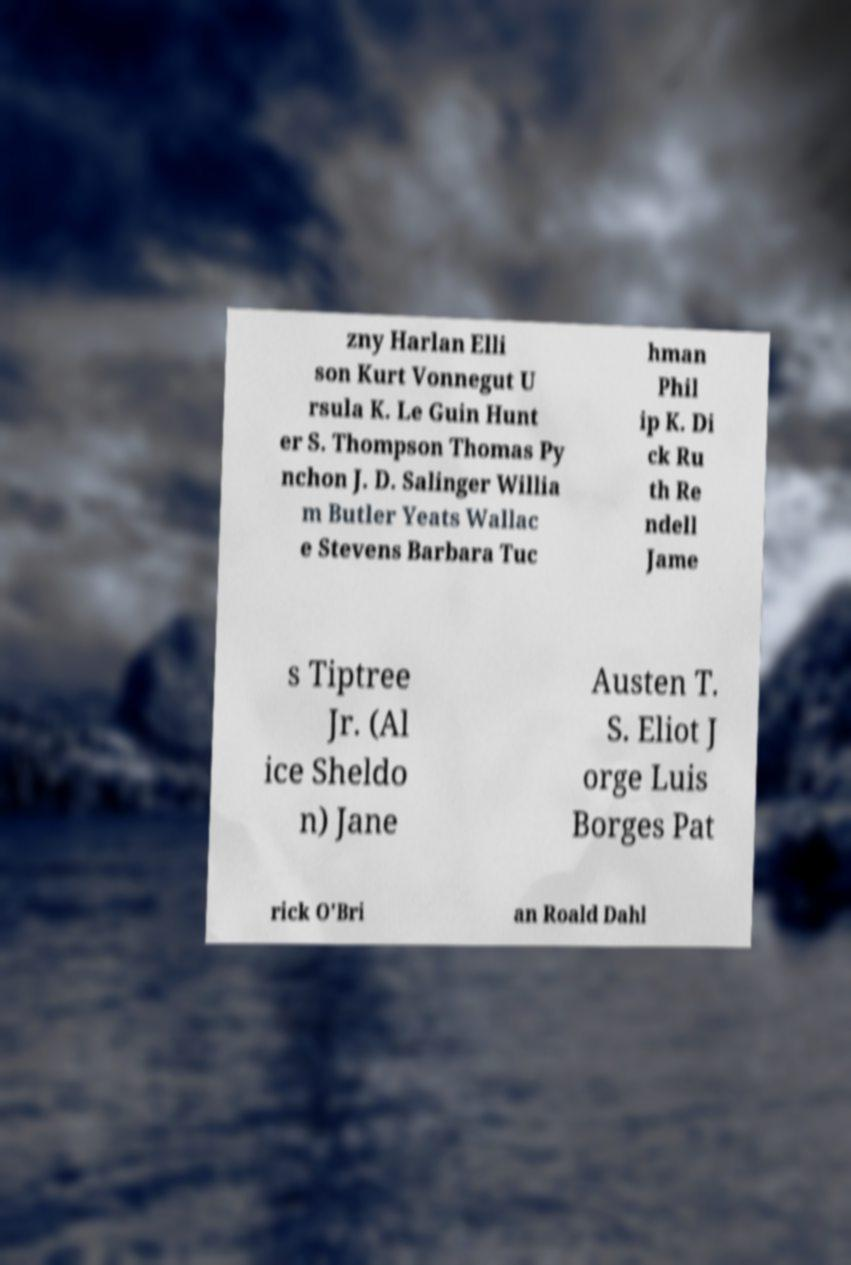Could you extract and type out the text from this image? zny Harlan Elli son Kurt Vonnegut U rsula K. Le Guin Hunt er S. Thompson Thomas Py nchon J. D. Salinger Willia m Butler Yeats Wallac e Stevens Barbara Tuc hman Phil ip K. Di ck Ru th Re ndell Jame s Tiptree Jr. (Al ice Sheldo n) Jane Austen T. S. Eliot J orge Luis Borges Pat rick O'Bri an Roald Dahl 